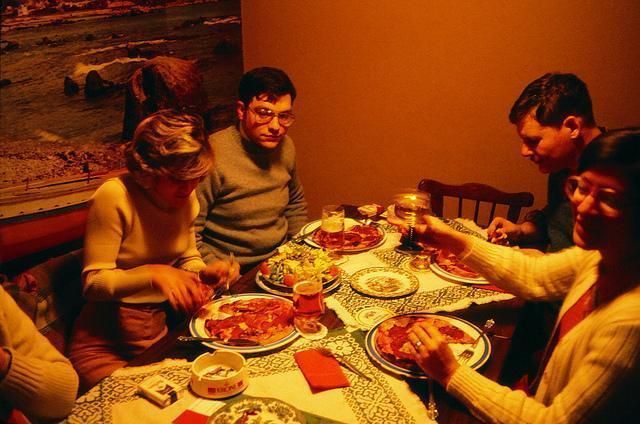How many people are at the table?
Give a very brief answer. 5. How many people are in the photo?
Give a very brief answer. 5. How many bowls are there?
Give a very brief answer. 1. How many pizzas are visible?
Give a very brief answer. 3. How many of the trains are green on front?
Give a very brief answer. 0. 